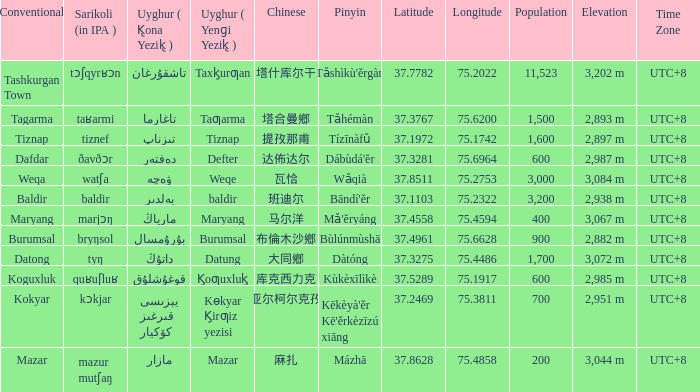Name the conventional for defter Dafdar. 